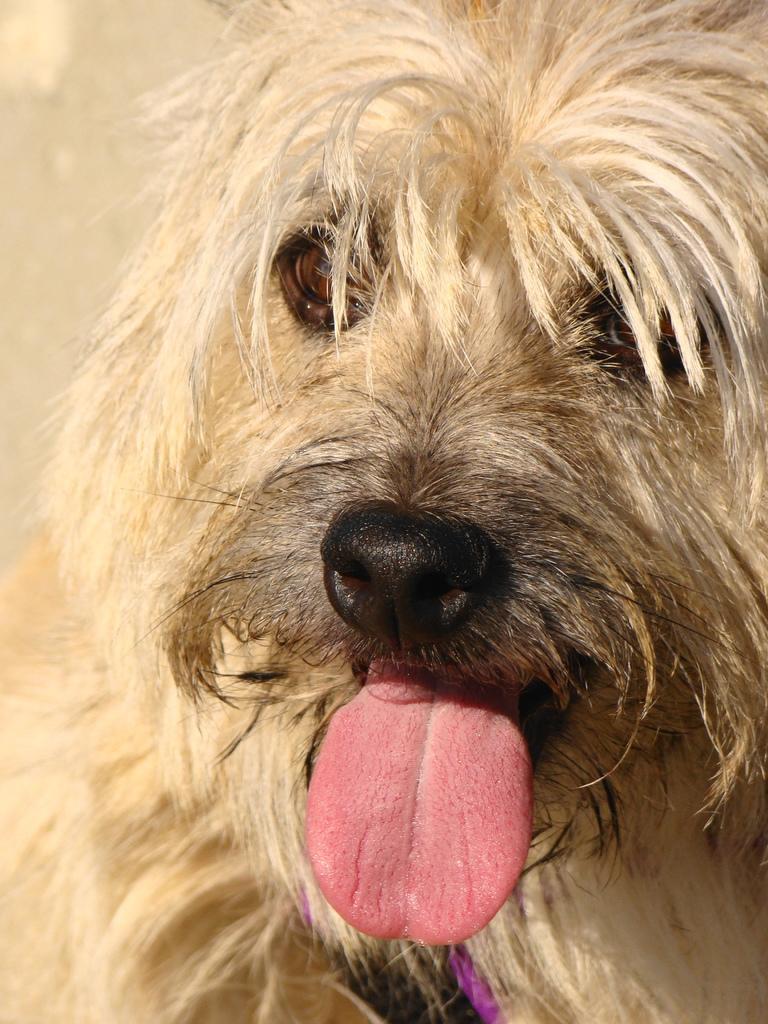How would you summarize this image in a sentence or two? In the foreground of this image, there is a dog with its tongue outside. 